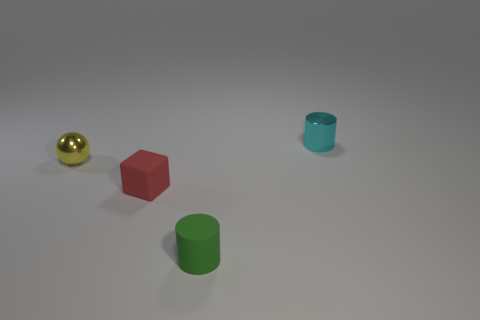Add 2 matte things. How many objects exist? 6 Subtract all cyan cylinders. How many cylinders are left? 1 Subtract 1 cylinders. How many cylinders are left? 1 Subtract 0 red cylinders. How many objects are left? 4 Subtract all blocks. How many objects are left? 3 Subtract all cyan cubes. Subtract all cyan spheres. How many cubes are left? 1 Subtract all small blue rubber cubes. Subtract all metal cylinders. How many objects are left? 3 Add 3 small red things. How many small red things are left? 4 Add 3 red objects. How many red objects exist? 4 